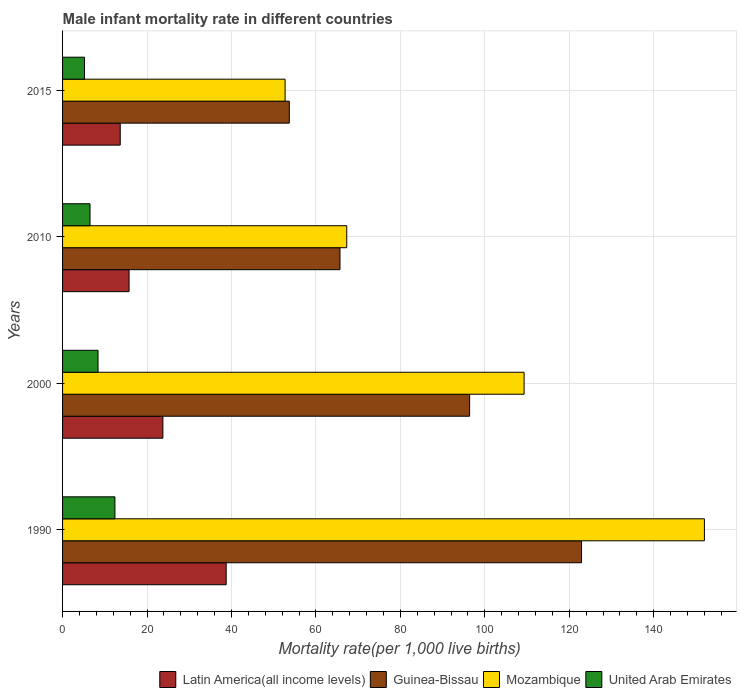Are the number of bars on each tick of the Y-axis equal?
Provide a succinct answer. Yes. How many bars are there on the 4th tick from the top?
Your response must be concise. 4. What is the male infant mortality rate in Latin America(all income levels) in 1990?
Your response must be concise. 38.75. Across all years, what is the maximum male infant mortality rate in United Arab Emirates?
Give a very brief answer. 12.4. Across all years, what is the minimum male infant mortality rate in Guinea-Bissau?
Provide a short and direct response. 53.7. In which year was the male infant mortality rate in Latin America(all income levels) maximum?
Provide a short and direct response. 1990. In which year was the male infant mortality rate in Latin America(all income levels) minimum?
Make the answer very short. 2015. What is the total male infant mortality rate in Latin America(all income levels) in the graph?
Your response must be concise. 91.91. What is the difference between the male infant mortality rate in Mozambique in 2000 and the male infant mortality rate in Latin America(all income levels) in 2015?
Provide a short and direct response. 95.64. What is the average male infant mortality rate in Mozambique per year?
Give a very brief answer. 95.33. In the year 2000, what is the difference between the male infant mortality rate in Guinea-Bissau and male infant mortality rate in United Arab Emirates?
Give a very brief answer. 88. In how many years, is the male infant mortality rate in United Arab Emirates greater than 52 ?
Your response must be concise. 0. What is the ratio of the male infant mortality rate in Guinea-Bissau in 2000 to that in 2010?
Your answer should be compact. 1.47. What is the difference between the highest and the second highest male infant mortality rate in Guinea-Bissau?
Your answer should be compact. 26.5. What is the difference between the highest and the lowest male infant mortality rate in Latin America(all income levels)?
Provide a succinct answer. 25.09. In how many years, is the male infant mortality rate in Latin America(all income levels) greater than the average male infant mortality rate in Latin America(all income levels) taken over all years?
Your answer should be very brief. 2. Is the sum of the male infant mortality rate in Mozambique in 1990 and 2015 greater than the maximum male infant mortality rate in Latin America(all income levels) across all years?
Make the answer very short. Yes. Is it the case that in every year, the sum of the male infant mortality rate in United Arab Emirates and male infant mortality rate in Latin America(all income levels) is greater than the sum of male infant mortality rate in Mozambique and male infant mortality rate in Guinea-Bissau?
Ensure brevity in your answer.  No. What does the 1st bar from the top in 2000 represents?
Ensure brevity in your answer.  United Arab Emirates. What does the 3rd bar from the bottom in 2015 represents?
Your response must be concise. Mozambique. Is it the case that in every year, the sum of the male infant mortality rate in Guinea-Bissau and male infant mortality rate in Mozambique is greater than the male infant mortality rate in Latin America(all income levels)?
Your answer should be compact. Yes. How many bars are there?
Ensure brevity in your answer.  16. How many years are there in the graph?
Give a very brief answer. 4. Does the graph contain grids?
Your response must be concise. Yes. Where does the legend appear in the graph?
Your response must be concise. Bottom right. How many legend labels are there?
Provide a succinct answer. 4. How are the legend labels stacked?
Offer a very short reply. Horizontal. What is the title of the graph?
Give a very brief answer. Male infant mortality rate in different countries. What is the label or title of the X-axis?
Give a very brief answer. Mortality rate(per 1,0 live births). What is the Mortality rate(per 1,000 live births) in Latin America(all income levels) in 1990?
Provide a succinct answer. 38.75. What is the Mortality rate(per 1,000 live births) of Guinea-Bissau in 1990?
Your answer should be compact. 122.9. What is the Mortality rate(per 1,000 live births) in Mozambique in 1990?
Provide a succinct answer. 152. What is the Mortality rate(per 1,000 live births) in United Arab Emirates in 1990?
Offer a terse response. 12.4. What is the Mortality rate(per 1,000 live births) of Latin America(all income levels) in 2000?
Offer a very short reply. 23.76. What is the Mortality rate(per 1,000 live births) in Guinea-Bissau in 2000?
Your response must be concise. 96.4. What is the Mortality rate(per 1,000 live births) in Mozambique in 2000?
Offer a terse response. 109.3. What is the Mortality rate(per 1,000 live births) of United Arab Emirates in 2000?
Ensure brevity in your answer.  8.4. What is the Mortality rate(per 1,000 live births) in Latin America(all income levels) in 2010?
Your response must be concise. 15.75. What is the Mortality rate(per 1,000 live births) in Guinea-Bissau in 2010?
Give a very brief answer. 65.7. What is the Mortality rate(per 1,000 live births) of Mozambique in 2010?
Make the answer very short. 67.3. What is the Mortality rate(per 1,000 live births) in Latin America(all income levels) in 2015?
Provide a short and direct response. 13.66. What is the Mortality rate(per 1,000 live births) of Guinea-Bissau in 2015?
Make the answer very short. 53.7. What is the Mortality rate(per 1,000 live births) in Mozambique in 2015?
Make the answer very short. 52.7. What is the Mortality rate(per 1,000 live births) of United Arab Emirates in 2015?
Provide a succinct answer. 5.2. Across all years, what is the maximum Mortality rate(per 1,000 live births) in Latin America(all income levels)?
Your answer should be compact. 38.75. Across all years, what is the maximum Mortality rate(per 1,000 live births) of Guinea-Bissau?
Offer a terse response. 122.9. Across all years, what is the maximum Mortality rate(per 1,000 live births) in Mozambique?
Your answer should be very brief. 152. Across all years, what is the minimum Mortality rate(per 1,000 live births) of Latin America(all income levels)?
Ensure brevity in your answer.  13.66. Across all years, what is the minimum Mortality rate(per 1,000 live births) in Guinea-Bissau?
Your answer should be compact. 53.7. Across all years, what is the minimum Mortality rate(per 1,000 live births) in Mozambique?
Your answer should be compact. 52.7. Across all years, what is the minimum Mortality rate(per 1,000 live births) in United Arab Emirates?
Make the answer very short. 5.2. What is the total Mortality rate(per 1,000 live births) in Latin America(all income levels) in the graph?
Your answer should be compact. 91.91. What is the total Mortality rate(per 1,000 live births) of Guinea-Bissau in the graph?
Give a very brief answer. 338.7. What is the total Mortality rate(per 1,000 live births) in Mozambique in the graph?
Ensure brevity in your answer.  381.3. What is the total Mortality rate(per 1,000 live births) of United Arab Emirates in the graph?
Provide a short and direct response. 32.5. What is the difference between the Mortality rate(per 1,000 live births) of Latin America(all income levels) in 1990 and that in 2000?
Your answer should be very brief. 14.99. What is the difference between the Mortality rate(per 1,000 live births) in Mozambique in 1990 and that in 2000?
Provide a short and direct response. 42.7. What is the difference between the Mortality rate(per 1,000 live births) in Latin America(all income levels) in 1990 and that in 2010?
Offer a very short reply. 23. What is the difference between the Mortality rate(per 1,000 live births) of Guinea-Bissau in 1990 and that in 2010?
Provide a short and direct response. 57.2. What is the difference between the Mortality rate(per 1,000 live births) of Mozambique in 1990 and that in 2010?
Your answer should be very brief. 84.7. What is the difference between the Mortality rate(per 1,000 live births) in United Arab Emirates in 1990 and that in 2010?
Provide a succinct answer. 5.9. What is the difference between the Mortality rate(per 1,000 live births) of Latin America(all income levels) in 1990 and that in 2015?
Your answer should be compact. 25.09. What is the difference between the Mortality rate(per 1,000 live births) in Guinea-Bissau in 1990 and that in 2015?
Ensure brevity in your answer.  69.2. What is the difference between the Mortality rate(per 1,000 live births) of Mozambique in 1990 and that in 2015?
Offer a terse response. 99.3. What is the difference between the Mortality rate(per 1,000 live births) of United Arab Emirates in 1990 and that in 2015?
Keep it short and to the point. 7.2. What is the difference between the Mortality rate(per 1,000 live births) of Latin America(all income levels) in 2000 and that in 2010?
Offer a very short reply. 8.01. What is the difference between the Mortality rate(per 1,000 live births) in Guinea-Bissau in 2000 and that in 2010?
Offer a terse response. 30.7. What is the difference between the Mortality rate(per 1,000 live births) of Mozambique in 2000 and that in 2010?
Make the answer very short. 42. What is the difference between the Mortality rate(per 1,000 live births) of Latin America(all income levels) in 2000 and that in 2015?
Offer a terse response. 10.1. What is the difference between the Mortality rate(per 1,000 live births) in Guinea-Bissau in 2000 and that in 2015?
Offer a terse response. 42.7. What is the difference between the Mortality rate(per 1,000 live births) in Mozambique in 2000 and that in 2015?
Offer a very short reply. 56.6. What is the difference between the Mortality rate(per 1,000 live births) of United Arab Emirates in 2000 and that in 2015?
Your answer should be compact. 3.2. What is the difference between the Mortality rate(per 1,000 live births) of Latin America(all income levels) in 2010 and that in 2015?
Your response must be concise. 2.09. What is the difference between the Mortality rate(per 1,000 live births) of Guinea-Bissau in 2010 and that in 2015?
Your answer should be compact. 12. What is the difference between the Mortality rate(per 1,000 live births) in United Arab Emirates in 2010 and that in 2015?
Keep it short and to the point. 1.3. What is the difference between the Mortality rate(per 1,000 live births) in Latin America(all income levels) in 1990 and the Mortality rate(per 1,000 live births) in Guinea-Bissau in 2000?
Your answer should be compact. -57.65. What is the difference between the Mortality rate(per 1,000 live births) of Latin America(all income levels) in 1990 and the Mortality rate(per 1,000 live births) of Mozambique in 2000?
Your answer should be compact. -70.55. What is the difference between the Mortality rate(per 1,000 live births) of Latin America(all income levels) in 1990 and the Mortality rate(per 1,000 live births) of United Arab Emirates in 2000?
Your answer should be compact. 30.35. What is the difference between the Mortality rate(per 1,000 live births) in Guinea-Bissau in 1990 and the Mortality rate(per 1,000 live births) in United Arab Emirates in 2000?
Keep it short and to the point. 114.5. What is the difference between the Mortality rate(per 1,000 live births) in Mozambique in 1990 and the Mortality rate(per 1,000 live births) in United Arab Emirates in 2000?
Give a very brief answer. 143.6. What is the difference between the Mortality rate(per 1,000 live births) of Latin America(all income levels) in 1990 and the Mortality rate(per 1,000 live births) of Guinea-Bissau in 2010?
Keep it short and to the point. -26.95. What is the difference between the Mortality rate(per 1,000 live births) in Latin America(all income levels) in 1990 and the Mortality rate(per 1,000 live births) in Mozambique in 2010?
Keep it short and to the point. -28.55. What is the difference between the Mortality rate(per 1,000 live births) in Latin America(all income levels) in 1990 and the Mortality rate(per 1,000 live births) in United Arab Emirates in 2010?
Offer a terse response. 32.25. What is the difference between the Mortality rate(per 1,000 live births) in Guinea-Bissau in 1990 and the Mortality rate(per 1,000 live births) in Mozambique in 2010?
Offer a terse response. 55.6. What is the difference between the Mortality rate(per 1,000 live births) of Guinea-Bissau in 1990 and the Mortality rate(per 1,000 live births) of United Arab Emirates in 2010?
Make the answer very short. 116.4. What is the difference between the Mortality rate(per 1,000 live births) of Mozambique in 1990 and the Mortality rate(per 1,000 live births) of United Arab Emirates in 2010?
Make the answer very short. 145.5. What is the difference between the Mortality rate(per 1,000 live births) of Latin America(all income levels) in 1990 and the Mortality rate(per 1,000 live births) of Guinea-Bissau in 2015?
Offer a terse response. -14.95. What is the difference between the Mortality rate(per 1,000 live births) of Latin America(all income levels) in 1990 and the Mortality rate(per 1,000 live births) of Mozambique in 2015?
Your response must be concise. -13.95. What is the difference between the Mortality rate(per 1,000 live births) in Latin America(all income levels) in 1990 and the Mortality rate(per 1,000 live births) in United Arab Emirates in 2015?
Provide a succinct answer. 33.55. What is the difference between the Mortality rate(per 1,000 live births) of Guinea-Bissau in 1990 and the Mortality rate(per 1,000 live births) of Mozambique in 2015?
Make the answer very short. 70.2. What is the difference between the Mortality rate(per 1,000 live births) in Guinea-Bissau in 1990 and the Mortality rate(per 1,000 live births) in United Arab Emirates in 2015?
Make the answer very short. 117.7. What is the difference between the Mortality rate(per 1,000 live births) of Mozambique in 1990 and the Mortality rate(per 1,000 live births) of United Arab Emirates in 2015?
Your answer should be compact. 146.8. What is the difference between the Mortality rate(per 1,000 live births) in Latin America(all income levels) in 2000 and the Mortality rate(per 1,000 live births) in Guinea-Bissau in 2010?
Offer a terse response. -41.94. What is the difference between the Mortality rate(per 1,000 live births) of Latin America(all income levels) in 2000 and the Mortality rate(per 1,000 live births) of Mozambique in 2010?
Make the answer very short. -43.54. What is the difference between the Mortality rate(per 1,000 live births) in Latin America(all income levels) in 2000 and the Mortality rate(per 1,000 live births) in United Arab Emirates in 2010?
Offer a terse response. 17.26. What is the difference between the Mortality rate(per 1,000 live births) in Guinea-Bissau in 2000 and the Mortality rate(per 1,000 live births) in Mozambique in 2010?
Keep it short and to the point. 29.1. What is the difference between the Mortality rate(per 1,000 live births) of Guinea-Bissau in 2000 and the Mortality rate(per 1,000 live births) of United Arab Emirates in 2010?
Your answer should be compact. 89.9. What is the difference between the Mortality rate(per 1,000 live births) in Mozambique in 2000 and the Mortality rate(per 1,000 live births) in United Arab Emirates in 2010?
Provide a short and direct response. 102.8. What is the difference between the Mortality rate(per 1,000 live births) in Latin America(all income levels) in 2000 and the Mortality rate(per 1,000 live births) in Guinea-Bissau in 2015?
Provide a succinct answer. -29.94. What is the difference between the Mortality rate(per 1,000 live births) of Latin America(all income levels) in 2000 and the Mortality rate(per 1,000 live births) of Mozambique in 2015?
Your answer should be compact. -28.94. What is the difference between the Mortality rate(per 1,000 live births) in Latin America(all income levels) in 2000 and the Mortality rate(per 1,000 live births) in United Arab Emirates in 2015?
Ensure brevity in your answer.  18.56. What is the difference between the Mortality rate(per 1,000 live births) in Guinea-Bissau in 2000 and the Mortality rate(per 1,000 live births) in Mozambique in 2015?
Give a very brief answer. 43.7. What is the difference between the Mortality rate(per 1,000 live births) of Guinea-Bissau in 2000 and the Mortality rate(per 1,000 live births) of United Arab Emirates in 2015?
Provide a short and direct response. 91.2. What is the difference between the Mortality rate(per 1,000 live births) of Mozambique in 2000 and the Mortality rate(per 1,000 live births) of United Arab Emirates in 2015?
Keep it short and to the point. 104.1. What is the difference between the Mortality rate(per 1,000 live births) of Latin America(all income levels) in 2010 and the Mortality rate(per 1,000 live births) of Guinea-Bissau in 2015?
Offer a very short reply. -37.95. What is the difference between the Mortality rate(per 1,000 live births) in Latin America(all income levels) in 2010 and the Mortality rate(per 1,000 live births) in Mozambique in 2015?
Your answer should be very brief. -36.95. What is the difference between the Mortality rate(per 1,000 live births) in Latin America(all income levels) in 2010 and the Mortality rate(per 1,000 live births) in United Arab Emirates in 2015?
Your answer should be very brief. 10.55. What is the difference between the Mortality rate(per 1,000 live births) in Guinea-Bissau in 2010 and the Mortality rate(per 1,000 live births) in Mozambique in 2015?
Your answer should be very brief. 13. What is the difference between the Mortality rate(per 1,000 live births) of Guinea-Bissau in 2010 and the Mortality rate(per 1,000 live births) of United Arab Emirates in 2015?
Provide a short and direct response. 60.5. What is the difference between the Mortality rate(per 1,000 live births) of Mozambique in 2010 and the Mortality rate(per 1,000 live births) of United Arab Emirates in 2015?
Provide a succinct answer. 62.1. What is the average Mortality rate(per 1,000 live births) of Latin America(all income levels) per year?
Offer a terse response. 22.98. What is the average Mortality rate(per 1,000 live births) in Guinea-Bissau per year?
Provide a succinct answer. 84.67. What is the average Mortality rate(per 1,000 live births) in Mozambique per year?
Keep it short and to the point. 95.33. What is the average Mortality rate(per 1,000 live births) in United Arab Emirates per year?
Give a very brief answer. 8.12. In the year 1990, what is the difference between the Mortality rate(per 1,000 live births) of Latin America(all income levels) and Mortality rate(per 1,000 live births) of Guinea-Bissau?
Your response must be concise. -84.15. In the year 1990, what is the difference between the Mortality rate(per 1,000 live births) in Latin America(all income levels) and Mortality rate(per 1,000 live births) in Mozambique?
Provide a short and direct response. -113.25. In the year 1990, what is the difference between the Mortality rate(per 1,000 live births) in Latin America(all income levels) and Mortality rate(per 1,000 live births) in United Arab Emirates?
Offer a terse response. 26.35. In the year 1990, what is the difference between the Mortality rate(per 1,000 live births) in Guinea-Bissau and Mortality rate(per 1,000 live births) in Mozambique?
Provide a succinct answer. -29.1. In the year 1990, what is the difference between the Mortality rate(per 1,000 live births) in Guinea-Bissau and Mortality rate(per 1,000 live births) in United Arab Emirates?
Give a very brief answer. 110.5. In the year 1990, what is the difference between the Mortality rate(per 1,000 live births) in Mozambique and Mortality rate(per 1,000 live births) in United Arab Emirates?
Your answer should be very brief. 139.6. In the year 2000, what is the difference between the Mortality rate(per 1,000 live births) of Latin America(all income levels) and Mortality rate(per 1,000 live births) of Guinea-Bissau?
Your answer should be very brief. -72.64. In the year 2000, what is the difference between the Mortality rate(per 1,000 live births) in Latin America(all income levels) and Mortality rate(per 1,000 live births) in Mozambique?
Give a very brief answer. -85.54. In the year 2000, what is the difference between the Mortality rate(per 1,000 live births) of Latin America(all income levels) and Mortality rate(per 1,000 live births) of United Arab Emirates?
Your answer should be very brief. 15.36. In the year 2000, what is the difference between the Mortality rate(per 1,000 live births) of Mozambique and Mortality rate(per 1,000 live births) of United Arab Emirates?
Keep it short and to the point. 100.9. In the year 2010, what is the difference between the Mortality rate(per 1,000 live births) in Latin America(all income levels) and Mortality rate(per 1,000 live births) in Guinea-Bissau?
Keep it short and to the point. -49.95. In the year 2010, what is the difference between the Mortality rate(per 1,000 live births) of Latin America(all income levels) and Mortality rate(per 1,000 live births) of Mozambique?
Give a very brief answer. -51.55. In the year 2010, what is the difference between the Mortality rate(per 1,000 live births) in Latin America(all income levels) and Mortality rate(per 1,000 live births) in United Arab Emirates?
Keep it short and to the point. 9.25. In the year 2010, what is the difference between the Mortality rate(per 1,000 live births) of Guinea-Bissau and Mortality rate(per 1,000 live births) of United Arab Emirates?
Offer a terse response. 59.2. In the year 2010, what is the difference between the Mortality rate(per 1,000 live births) of Mozambique and Mortality rate(per 1,000 live births) of United Arab Emirates?
Keep it short and to the point. 60.8. In the year 2015, what is the difference between the Mortality rate(per 1,000 live births) in Latin America(all income levels) and Mortality rate(per 1,000 live births) in Guinea-Bissau?
Give a very brief answer. -40.04. In the year 2015, what is the difference between the Mortality rate(per 1,000 live births) in Latin America(all income levels) and Mortality rate(per 1,000 live births) in Mozambique?
Give a very brief answer. -39.04. In the year 2015, what is the difference between the Mortality rate(per 1,000 live births) in Latin America(all income levels) and Mortality rate(per 1,000 live births) in United Arab Emirates?
Your answer should be very brief. 8.46. In the year 2015, what is the difference between the Mortality rate(per 1,000 live births) of Guinea-Bissau and Mortality rate(per 1,000 live births) of Mozambique?
Your response must be concise. 1. In the year 2015, what is the difference between the Mortality rate(per 1,000 live births) in Guinea-Bissau and Mortality rate(per 1,000 live births) in United Arab Emirates?
Provide a succinct answer. 48.5. In the year 2015, what is the difference between the Mortality rate(per 1,000 live births) in Mozambique and Mortality rate(per 1,000 live births) in United Arab Emirates?
Make the answer very short. 47.5. What is the ratio of the Mortality rate(per 1,000 live births) of Latin America(all income levels) in 1990 to that in 2000?
Make the answer very short. 1.63. What is the ratio of the Mortality rate(per 1,000 live births) in Guinea-Bissau in 1990 to that in 2000?
Your answer should be very brief. 1.27. What is the ratio of the Mortality rate(per 1,000 live births) in Mozambique in 1990 to that in 2000?
Offer a terse response. 1.39. What is the ratio of the Mortality rate(per 1,000 live births) in United Arab Emirates in 1990 to that in 2000?
Give a very brief answer. 1.48. What is the ratio of the Mortality rate(per 1,000 live births) in Latin America(all income levels) in 1990 to that in 2010?
Offer a terse response. 2.46. What is the ratio of the Mortality rate(per 1,000 live births) of Guinea-Bissau in 1990 to that in 2010?
Make the answer very short. 1.87. What is the ratio of the Mortality rate(per 1,000 live births) in Mozambique in 1990 to that in 2010?
Offer a very short reply. 2.26. What is the ratio of the Mortality rate(per 1,000 live births) in United Arab Emirates in 1990 to that in 2010?
Give a very brief answer. 1.91. What is the ratio of the Mortality rate(per 1,000 live births) in Latin America(all income levels) in 1990 to that in 2015?
Give a very brief answer. 2.84. What is the ratio of the Mortality rate(per 1,000 live births) of Guinea-Bissau in 1990 to that in 2015?
Provide a succinct answer. 2.29. What is the ratio of the Mortality rate(per 1,000 live births) of Mozambique in 1990 to that in 2015?
Keep it short and to the point. 2.88. What is the ratio of the Mortality rate(per 1,000 live births) in United Arab Emirates in 1990 to that in 2015?
Ensure brevity in your answer.  2.38. What is the ratio of the Mortality rate(per 1,000 live births) in Latin America(all income levels) in 2000 to that in 2010?
Provide a succinct answer. 1.51. What is the ratio of the Mortality rate(per 1,000 live births) of Guinea-Bissau in 2000 to that in 2010?
Provide a short and direct response. 1.47. What is the ratio of the Mortality rate(per 1,000 live births) in Mozambique in 2000 to that in 2010?
Provide a short and direct response. 1.62. What is the ratio of the Mortality rate(per 1,000 live births) in United Arab Emirates in 2000 to that in 2010?
Offer a terse response. 1.29. What is the ratio of the Mortality rate(per 1,000 live births) in Latin America(all income levels) in 2000 to that in 2015?
Keep it short and to the point. 1.74. What is the ratio of the Mortality rate(per 1,000 live births) in Guinea-Bissau in 2000 to that in 2015?
Your response must be concise. 1.8. What is the ratio of the Mortality rate(per 1,000 live births) in Mozambique in 2000 to that in 2015?
Offer a terse response. 2.07. What is the ratio of the Mortality rate(per 1,000 live births) in United Arab Emirates in 2000 to that in 2015?
Ensure brevity in your answer.  1.62. What is the ratio of the Mortality rate(per 1,000 live births) in Latin America(all income levels) in 2010 to that in 2015?
Provide a short and direct response. 1.15. What is the ratio of the Mortality rate(per 1,000 live births) of Guinea-Bissau in 2010 to that in 2015?
Your response must be concise. 1.22. What is the ratio of the Mortality rate(per 1,000 live births) in Mozambique in 2010 to that in 2015?
Ensure brevity in your answer.  1.28. What is the ratio of the Mortality rate(per 1,000 live births) of United Arab Emirates in 2010 to that in 2015?
Provide a succinct answer. 1.25. What is the difference between the highest and the second highest Mortality rate(per 1,000 live births) of Latin America(all income levels)?
Ensure brevity in your answer.  14.99. What is the difference between the highest and the second highest Mortality rate(per 1,000 live births) of Guinea-Bissau?
Offer a very short reply. 26.5. What is the difference between the highest and the second highest Mortality rate(per 1,000 live births) in Mozambique?
Provide a succinct answer. 42.7. What is the difference between the highest and the lowest Mortality rate(per 1,000 live births) of Latin America(all income levels)?
Keep it short and to the point. 25.09. What is the difference between the highest and the lowest Mortality rate(per 1,000 live births) of Guinea-Bissau?
Provide a short and direct response. 69.2. What is the difference between the highest and the lowest Mortality rate(per 1,000 live births) of Mozambique?
Provide a succinct answer. 99.3. What is the difference between the highest and the lowest Mortality rate(per 1,000 live births) of United Arab Emirates?
Your answer should be very brief. 7.2. 